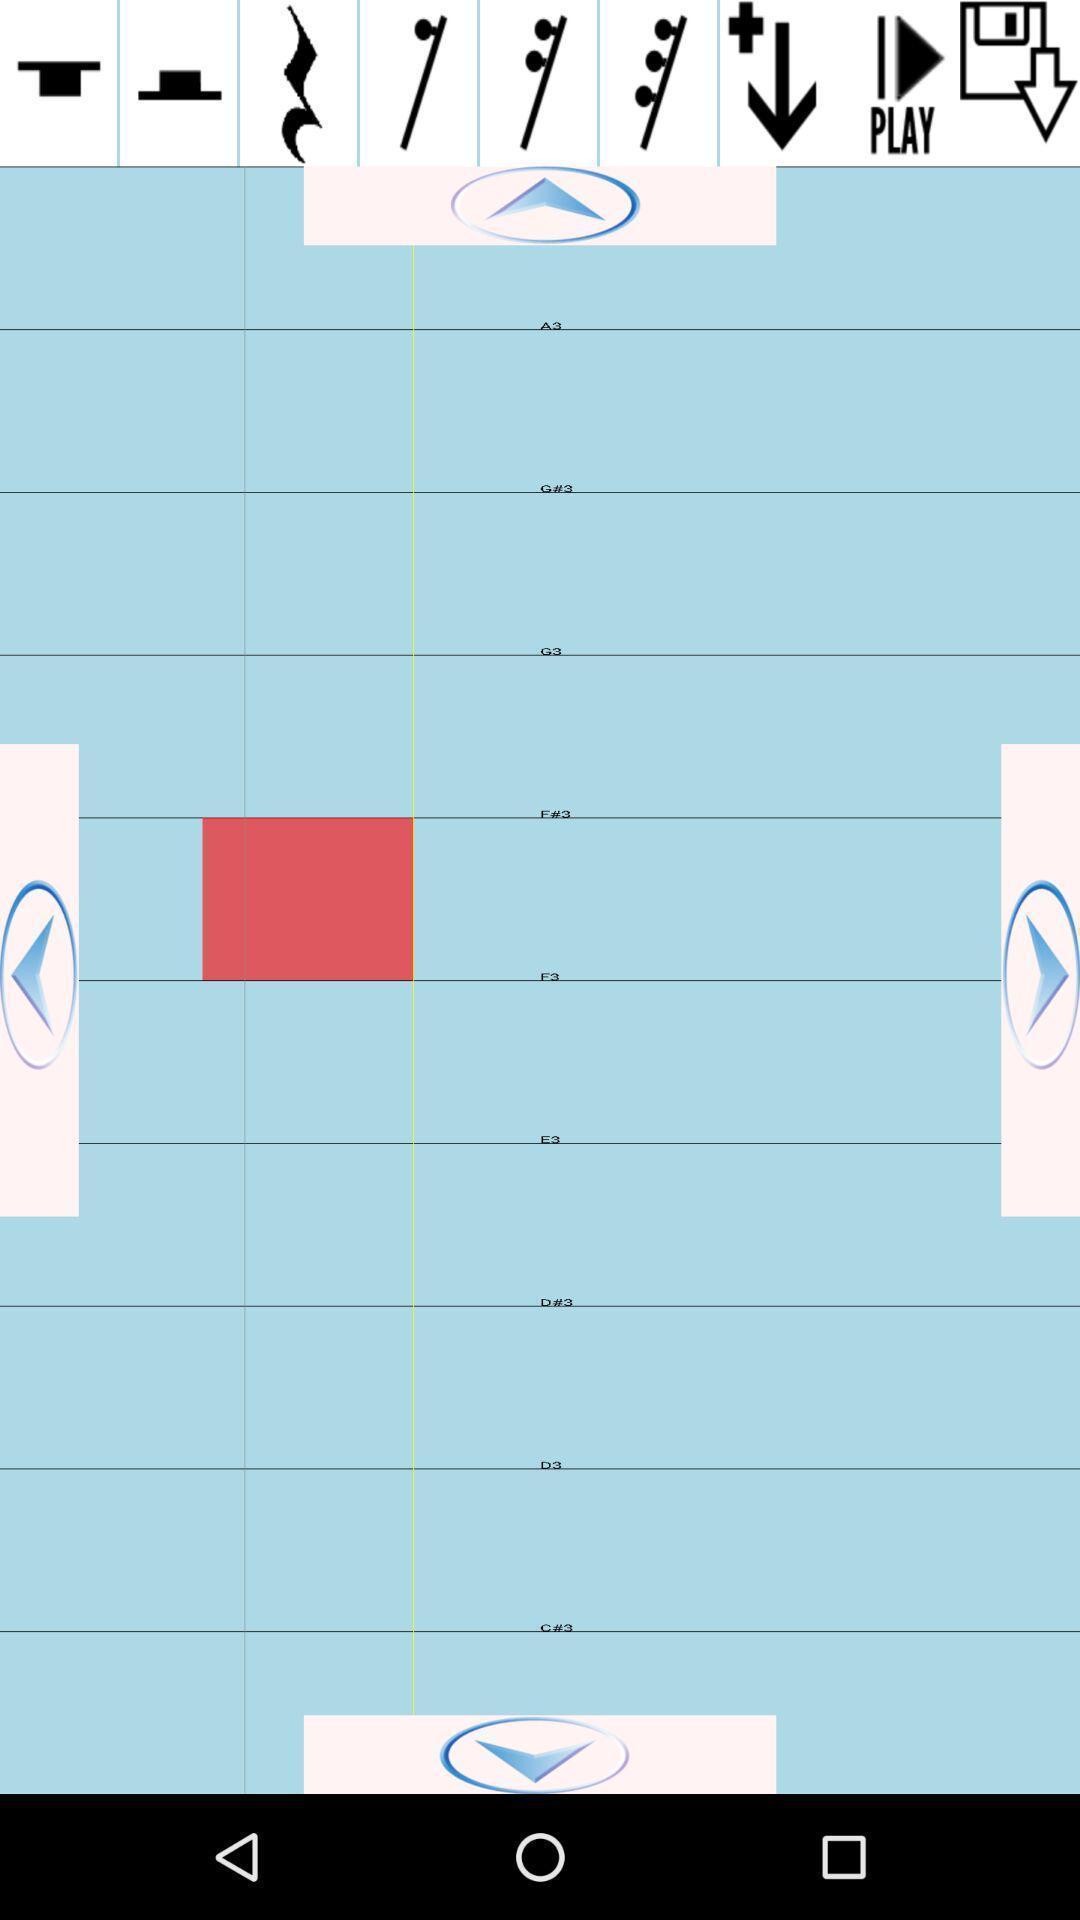Explain what's happening in this screen capture. Page showing how to sing with several exercises. 